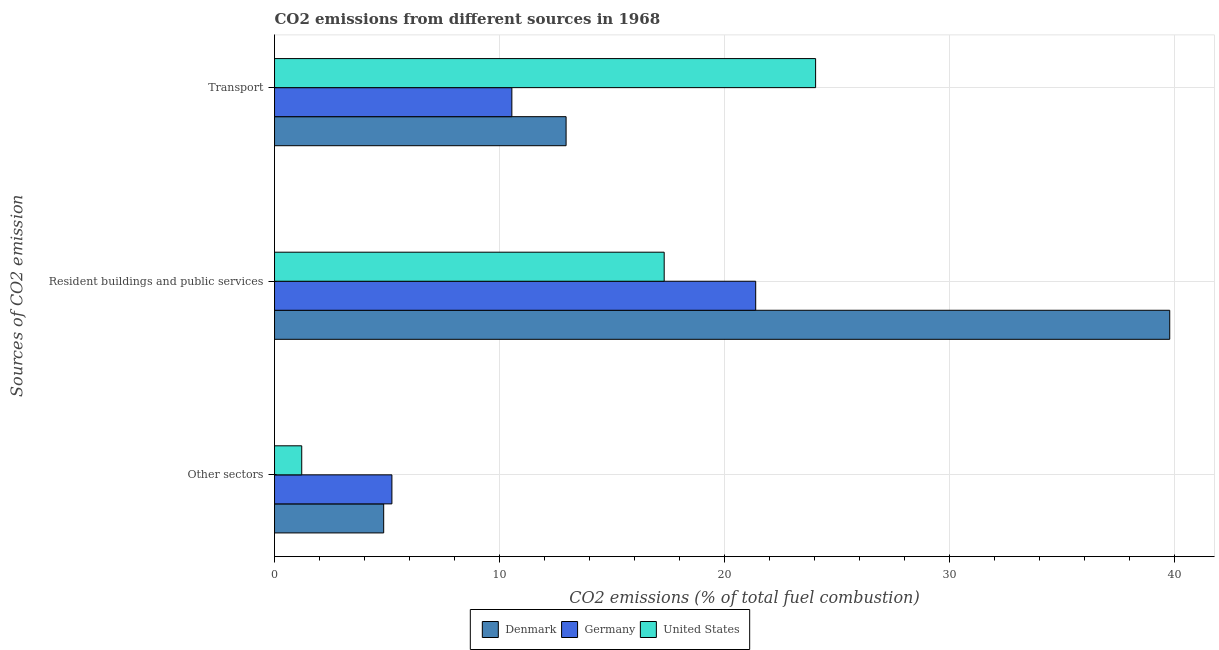How many groups of bars are there?
Keep it short and to the point. 3. Are the number of bars on each tick of the Y-axis equal?
Provide a short and direct response. Yes. How many bars are there on the 3rd tick from the top?
Your answer should be compact. 3. What is the label of the 1st group of bars from the top?
Offer a very short reply. Transport. What is the percentage of co2 emissions from transport in Denmark?
Provide a succinct answer. 12.96. Across all countries, what is the maximum percentage of co2 emissions from resident buildings and public services?
Provide a short and direct response. 39.79. Across all countries, what is the minimum percentage of co2 emissions from resident buildings and public services?
Offer a terse response. 17.32. In which country was the percentage of co2 emissions from other sectors minimum?
Your answer should be compact. United States. What is the total percentage of co2 emissions from transport in the graph?
Make the answer very short. 47.56. What is the difference between the percentage of co2 emissions from transport in United States and that in Germany?
Provide a short and direct response. 13.5. What is the difference between the percentage of co2 emissions from transport in United States and the percentage of co2 emissions from other sectors in Germany?
Ensure brevity in your answer.  18.83. What is the average percentage of co2 emissions from transport per country?
Keep it short and to the point. 15.85. What is the difference between the percentage of co2 emissions from other sectors and percentage of co2 emissions from transport in United States?
Ensure brevity in your answer.  -22.84. What is the ratio of the percentage of co2 emissions from other sectors in Germany to that in Denmark?
Offer a very short reply. 1.08. Is the difference between the percentage of co2 emissions from transport in Germany and Denmark greater than the difference between the percentage of co2 emissions from resident buildings and public services in Germany and Denmark?
Provide a succinct answer. Yes. What is the difference between the highest and the second highest percentage of co2 emissions from transport?
Your answer should be very brief. 11.09. What is the difference between the highest and the lowest percentage of co2 emissions from transport?
Your response must be concise. 13.5. What does the 1st bar from the top in Other sectors represents?
Provide a succinct answer. United States. Is it the case that in every country, the sum of the percentage of co2 emissions from other sectors and percentage of co2 emissions from resident buildings and public services is greater than the percentage of co2 emissions from transport?
Provide a short and direct response. No. How many bars are there?
Provide a short and direct response. 9. Are all the bars in the graph horizontal?
Provide a succinct answer. Yes. Are the values on the major ticks of X-axis written in scientific E-notation?
Provide a succinct answer. No. Does the graph contain grids?
Ensure brevity in your answer.  Yes. What is the title of the graph?
Offer a terse response. CO2 emissions from different sources in 1968. Does "Cuba" appear as one of the legend labels in the graph?
Your response must be concise. No. What is the label or title of the X-axis?
Ensure brevity in your answer.  CO2 emissions (% of total fuel combustion). What is the label or title of the Y-axis?
Your answer should be very brief. Sources of CO2 emission. What is the CO2 emissions (% of total fuel combustion) of Denmark in Other sectors?
Your answer should be very brief. 4.85. What is the CO2 emissions (% of total fuel combustion) in Germany in Other sectors?
Offer a very short reply. 5.22. What is the CO2 emissions (% of total fuel combustion) of United States in Other sectors?
Provide a short and direct response. 1.21. What is the CO2 emissions (% of total fuel combustion) in Denmark in Resident buildings and public services?
Offer a terse response. 39.79. What is the CO2 emissions (% of total fuel combustion) in Germany in Resident buildings and public services?
Your response must be concise. 21.39. What is the CO2 emissions (% of total fuel combustion) of United States in Resident buildings and public services?
Make the answer very short. 17.32. What is the CO2 emissions (% of total fuel combustion) in Denmark in Transport?
Keep it short and to the point. 12.96. What is the CO2 emissions (% of total fuel combustion) of Germany in Transport?
Your answer should be compact. 10.55. What is the CO2 emissions (% of total fuel combustion) of United States in Transport?
Provide a short and direct response. 24.05. Across all Sources of CO2 emission, what is the maximum CO2 emissions (% of total fuel combustion) in Denmark?
Your response must be concise. 39.79. Across all Sources of CO2 emission, what is the maximum CO2 emissions (% of total fuel combustion) in Germany?
Ensure brevity in your answer.  21.39. Across all Sources of CO2 emission, what is the maximum CO2 emissions (% of total fuel combustion) of United States?
Provide a short and direct response. 24.05. Across all Sources of CO2 emission, what is the minimum CO2 emissions (% of total fuel combustion) in Denmark?
Offer a very short reply. 4.85. Across all Sources of CO2 emission, what is the minimum CO2 emissions (% of total fuel combustion) of Germany?
Ensure brevity in your answer.  5.22. Across all Sources of CO2 emission, what is the minimum CO2 emissions (% of total fuel combustion) of United States?
Offer a terse response. 1.21. What is the total CO2 emissions (% of total fuel combustion) in Denmark in the graph?
Provide a short and direct response. 57.6. What is the total CO2 emissions (% of total fuel combustion) in Germany in the graph?
Ensure brevity in your answer.  37.15. What is the total CO2 emissions (% of total fuel combustion) of United States in the graph?
Offer a terse response. 42.58. What is the difference between the CO2 emissions (% of total fuel combustion) in Denmark in Other sectors and that in Resident buildings and public services?
Offer a very short reply. -34.94. What is the difference between the CO2 emissions (% of total fuel combustion) in Germany in Other sectors and that in Resident buildings and public services?
Your response must be concise. -16.17. What is the difference between the CO2 emissions (% of total fuel combustion) of United States in Other sectors and that in Resident buildings and public services?
Make the answer very short. -16.11. What is the difference between the CO2 emissions (% of total fuel combustion) in Denmark in Other sectors and that in Transport?
Give a very brief answer. -8.11. What is the difference between the CO2 emissions (% of total fuel combustion) of Germany in Other sectors and that in Transport?
Your answer should be very brief. -5.33. What is the difference between the CO2 emissions (% of total fuel combustion) in United States in Other sectors and that in Transport?
Ensure brevity in your answer.  -22.84. What is the difference between the CO2 emissions (% of total fuel combustion) of Denmark in Resident buildings and public services and that in Transport?
Your response must be concise. 26.83. What is the difference between the CO2 emissions (% of total fuel combustion) in Germany in Resident buildings and public services and that in Transport?
Offer a terse response. 10.84. What is the difference between the CO2 emissions (% of total fuel combustion) of United States in Resident buildings and public services and that in Transport?
Ensure brevity in your answer.  -6.73. What is the difference between the CO2 emissions (% of total fuel combustion) of Denmark in Other sectors and the CO2 emissions (% of total fuel combustion) of Germany in Resident buildings and public services?
Provide a short and direct response. -16.54. What is the difference between the CO2 emissions (% of total fuel combustion) in Denmark in Other sectors and the CO2 emissions (% of total fuel combustion) in United States in Resident buildings and public services?
Keep it short and to the point. -12.47. What is the difference between the CO2 emissions (% of total fuel combustion) in Germany in Other sectors and the CO2 emissions (% of total fuel combustion) in United States in Resident buildings and public services?
Provide a succinct answer. -12.1. What is the difference between the CO2 emissions (% of total fuel combustion) in Denmark in Other sectors and the CO2 emissions (% of total fuel combustion) in Germany in Transport?
Your answer should be very brief. -5.7. What is the difference between the CO2 emissions (% of total fuel combustion) in Denmark in Other sectors and the CO2 emissions (% of total fuel combustion) in United States in Transport?
Provide a succinct answer. -19.2. What is the difference between the CO2 emissions (% of total fuel combustion) in Germany in Other sectors and the CO2 emissions (% of total fuel combustion) in United States in Transport?
Give a very brief answer. -18.83. What is the difference between the CO2 emissions (% of total fuel combustion) of Denmark in Resident buildings and public services and the CO2 emissions (% of total fuel combustion) of Germany in Transport?
Make the answer very short. 29.24. What is the difference between the CO2 emissions (% of total fuel combustion) in Denmark in Resident buildings and public services and the CO2 emissions (% of total fuel combustion) in United States in Transport?
Provide a succinct answer. 15.74. What is the difference between the CO2 emissions (% of total fuel combustion) in Germany in Resident buildings and public services and the CO2 emissions (% of total fuel combustion) in United States in Transport?
Offer a terse response. -2.66. What is the average CO2 emissions (% of total fuel combustion) in Denmark per Sources of CO2 emission?
Offer a very short reply. 19.2. What is the average CO2 emissions (% of total fuel combustion) of Germany per Sources of CO2 emission?
Your answer should be very brief. 12.38. What is the average CO2 emissions (% of total fuel combustion) of United States per Sources of CO2 emission?
Keep it short and to the point. 14.19. What is the difference between the CO2 emissions (% of total fuel combustion) in Denmark and CO2 emissions (% of total fuel combustion) in Germany in Other sectors?
Keep it short and to the point. -0.37. What is the difference between the CO2 emissions (% of total fuel combustion) of Denmark and CO2 emissions (% of total fuel combustion) of United States in Other sectors?
Your answer should be compact. 3.64. What is the difference between the CO2 emissions (% of total fuel combustion) of Germany and CO2 emissions (% of total fuel combustion) of United States in Other sectors?
Keep it short and to the point. 4.01. What is the difference between the CO2 emissions (% of total fuel combustion) in Denmark and CO2 emissions (% of total fuel combustion) in Germany in Resident buildings and public services?
Your answer should be compact. 18.4. What is the difference between the CO2 emissions (% of total fuel combustion) in Denmark and CO2 emissions (% of total fuel combustion) in United States in Resident buildings and public services?
Offer a terse response. 22.47. What is the difference between the CO2 emissions (% of total fuel combustion) in Germany and CO2 emissions (% of total fuel combustion) in United States in Resident buildings and public services?
Your answer should be very brief. 4.07. What is the difference between the CO2 emissions (% of total fuel combustion) in Denmark and CO2 emissions (% of total fuel combustion) in Germany in Transport?
Offer a terse response. 2.41. What is the difference between the CO2 emissions (% of total fuel combustion) of Denmark and CO2 emissions (% of total fuel combustion) of United States in Transport?
Ensure brevity in your answer.  -11.09. What is the difference between the CO2 emissions (% of total fuel combustion) of Germany and CO2 emissions (% of total fuel combustion) of United States in Transport?
Your answer should be very brief. -13.5. What is the ratio of the CO2 emissions (% of total fuel combustion) in Denmark in Other sectors to that in Resident buildings and public services?
Your response must be concise. 0.12. What is the ratio of the CO2 emissions (% of total fuel combustion) of Germany in Other sectors to that in Resident buildings and public services?
Give a very brief answer. 0.24. What is the ratio of the CO2 emissions (% of total fuel combustion) of United States in Other sectors to that in Resident buildings and public services?
Offer a terse response. 0.07. What is the ratio of the CO2 emissions (% of total fuel combustion) in Denmark in Other sectors to that in Transport?
Provide a short and direct response. 0.37. What is the ratio of the CO2 emissions (% of total fuel combustion) of Germany in Other sectors to that in Transport?
Offer a terse response. 0.49. What is the ratio of the CO2 emissions (% of total fuel combustion) of United States in Other sectors to that in Transport?
Provide a short and direct response. 0.05. What is the ratio of the CO2 emissions (% of total fuel combustion) of Denmark in Resident buildings and public services to that in Transport?
Offer a terse response. 3.07. What is the ratio of the CO2 emissions (% of total fuel combustion) in Germany in Resident buildings and public services to that in Transport?
Your response must be concise. 2.03. What is the ratio of the CO2 emissions (% of total fuel combustion) of United States in Resident buildings and public services to that in Transport?
Your answer should be very brief. 0.72. What is the difference between the highest and the second highest CO2 emissions (% of total fuel combustion) of Denmark?
Offer a very short reply. 26.83. What is the difference between the highest and the second highest CO2 emissions (% of total fuel combustion) in Germany?
Make the answer very short. 10.84. What is the difference between the highest and the second highest CO2 emissions (% of total fuel combustion) in United States?
Give a very brief answer. 6.73. What is the difference between the highest and the lowest CO2 emissions (% of total fuel combustion) in Denmark?
Keep it short and to the point. 34.94. What is the difference between the highest and the lowest CO2 emissions (% of total fuel combustion) in Germany?
Your answer should be compact. 16.17. What is the difference between the highest and the lowest CO2 emissions (% of total fuel combustion) of United States?
Offer a terse response. 22.84. 